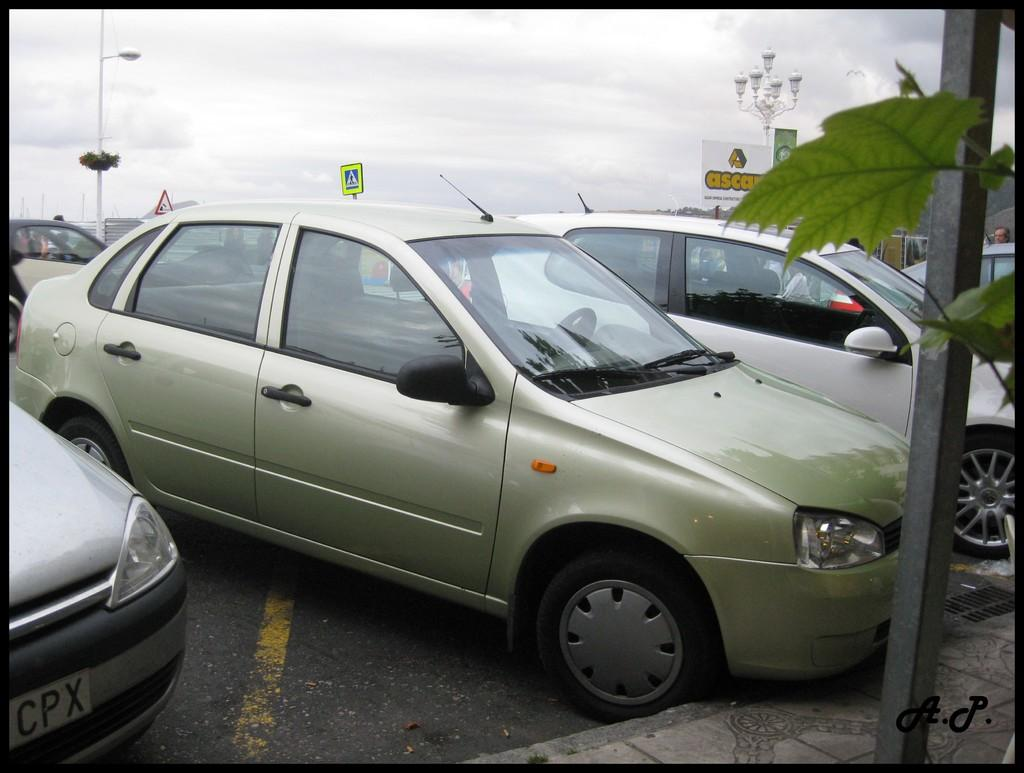What is parked on the road in the image? There is a car parked on the road in the image. What can be seen on the right side of the image? There is a board on the right side of the image. What type of vegetation is present in the image? There are leaves of a plant in the image. How would you describe the sky in the image? The sky is cloudy in the image. What type of sand can be seen on the board in the image? There is no sand present in the image, and the board does not have any sand on it. 